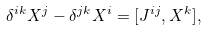<formula> <loc_0><loc_0><loc_500><loc_500>\delta ^ { i k } X ^ { j } - \delta ^ { j k } X ^ { i } = [ J ^ { i j } , X ^ { k } ] ,</formula> 